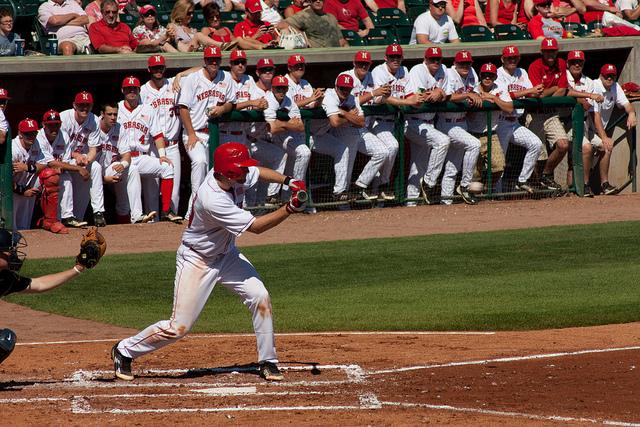What color is the uniform?
Give a very brief answer. White. What game are they playing?
Keep it brief. Baseball. Do most of the player's have one knee up?
Concise answer only. Yes. How many players are on the fence?
Concise answer only. Many. 